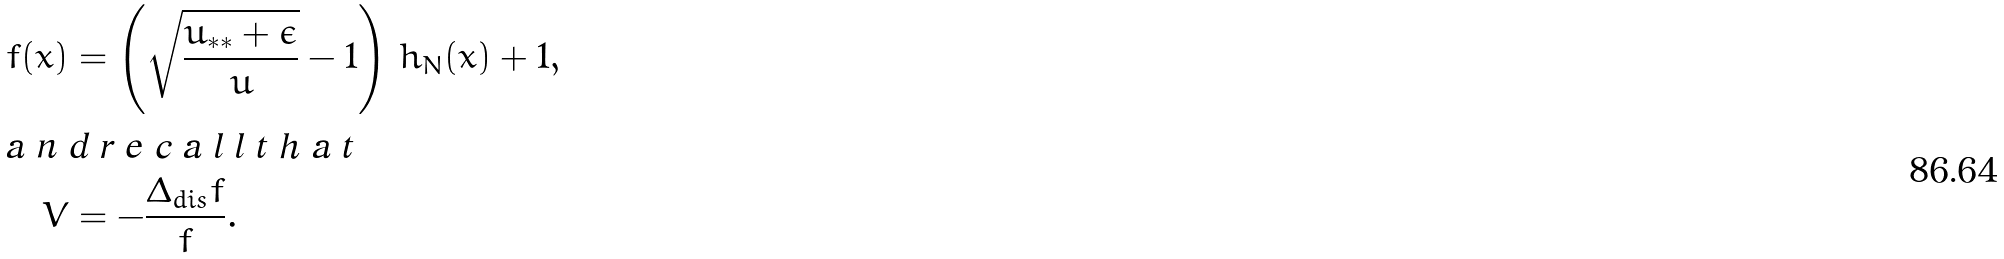<formula> <loc_0><loc_0><loc_500><loc_500>f ( x ) & = \left ( \sqrt { \frac { u _ { * * } + \epsilon } { u } } - 1 \right ) \, h _ { N } ( x ) + 1 , \intertext { a n d r e c a l l t h a t } V & = - \frac { \Delta _ { d i s } f } { f } .</formula> 